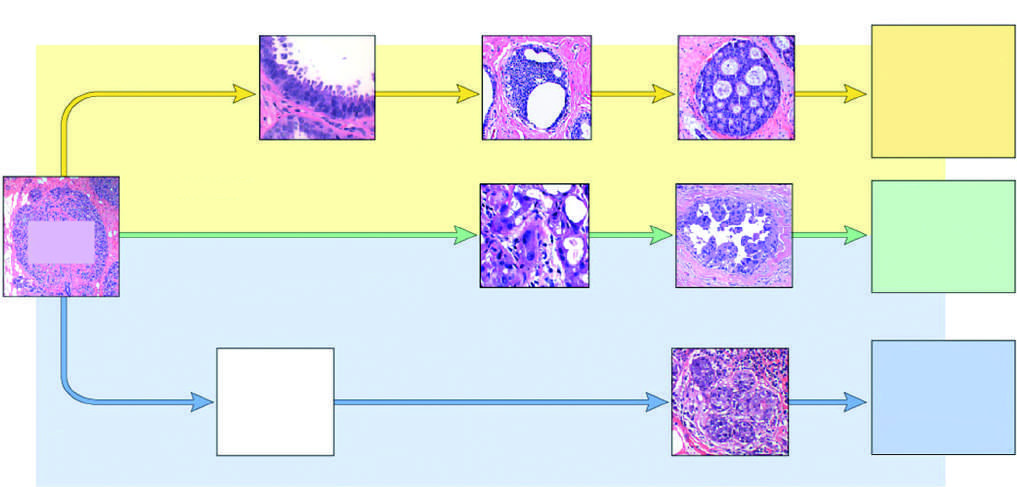do the principal cellular alterations that characterize reversible cell injury and necrosis include flat epithelial atypia, adh, and dcis?
Answer the question using a single word or phrase. No 